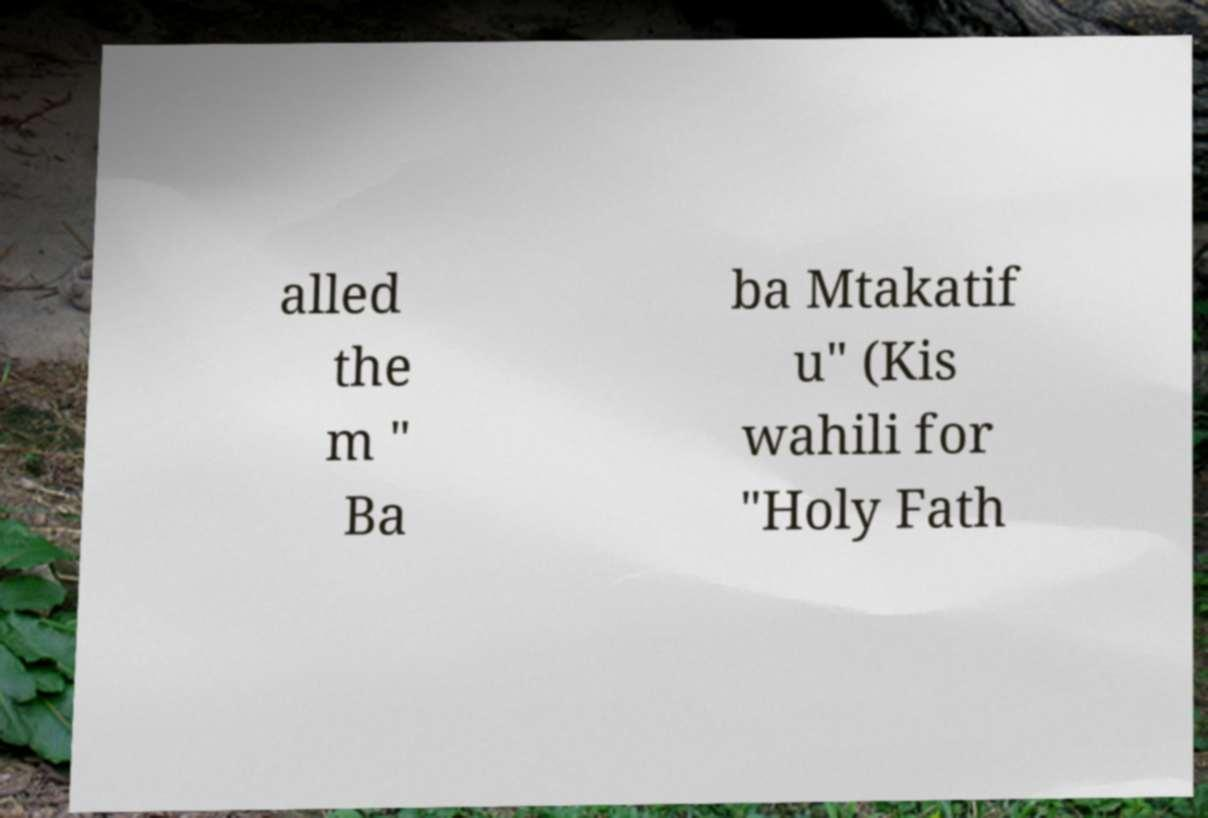Please read and relay the text visible in this image. What does it say? alled the m " Ba ba Mtakatif u" (Kis wahili for "Holy Fath 